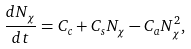Convert formula to latex. <formula><loc_0><loc_0><loc_500><loc_500>\frac { d N _ { \chi } } { d t } = C _ { c } + C _ { s } N _ { \chi } - C _ { a } N _ { \chi } ^ { 2 } ,</formula> 